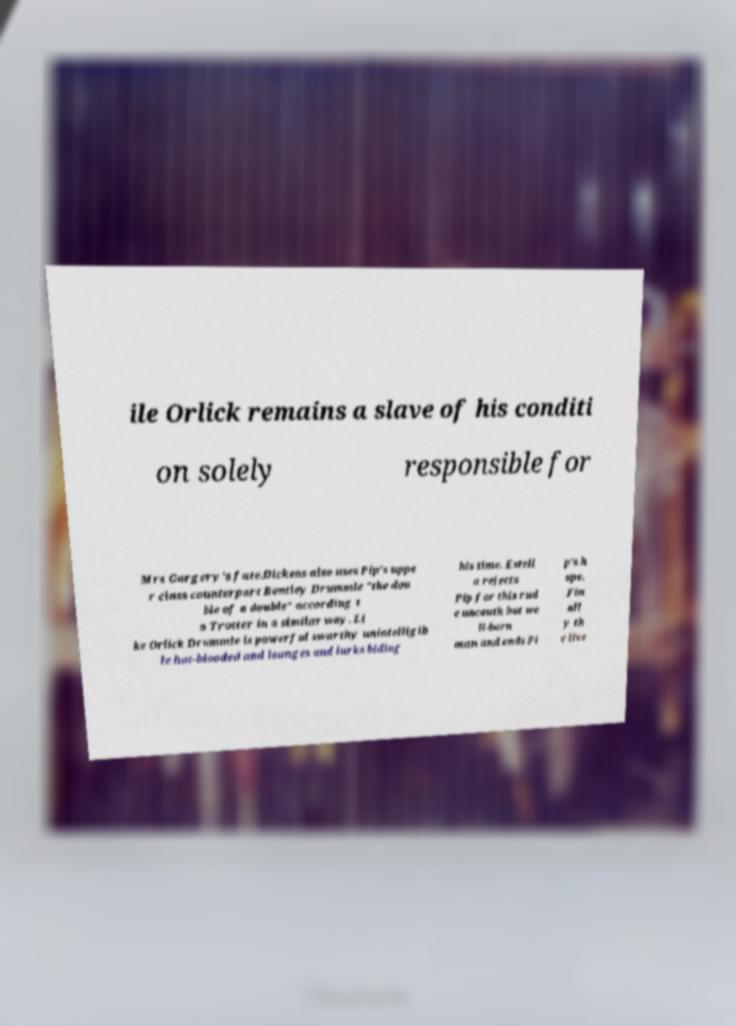Could you extract and type out the text from this image? ile Orlick remains a slave of his conditi on solely responsible for Mrs Gargery's fate.Dickens also uses Pip's uppe r class counterpart Bentley Drummle "the dou ble of a double" according t o Trotter in a similar way. Li ke Orlick Drummle is powerful swarthy unintelligib le hot-blooded and lounges and lurks biding his time. Estell a rejects Pip for this rud e uncouth but we ll-born man and ends Pi p's h ope. Fin all y th e live 